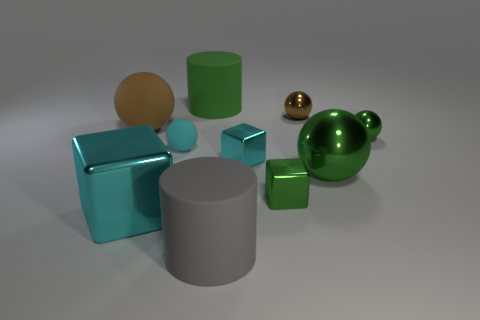Subtract all cyan spheres. How many spheres are left? 4 Subtract all big brown spheres. How many spheres are left? 4 Subtract all purple balls. Subtract all cyan cubes. How many balls are left? 5 Subtract all cubes. How many objects are left? 7 Add 1 tiny cyan metal cubes. How many tiny cyan metal cubes are left? 2 Add 4 brown things. How many brown things exist? 6 Subtract 2 green spheres. How many objects are left? 8 Subtract all tiny cyan metal things. Subtract all rubber cylinders. How many objects are left? 7 